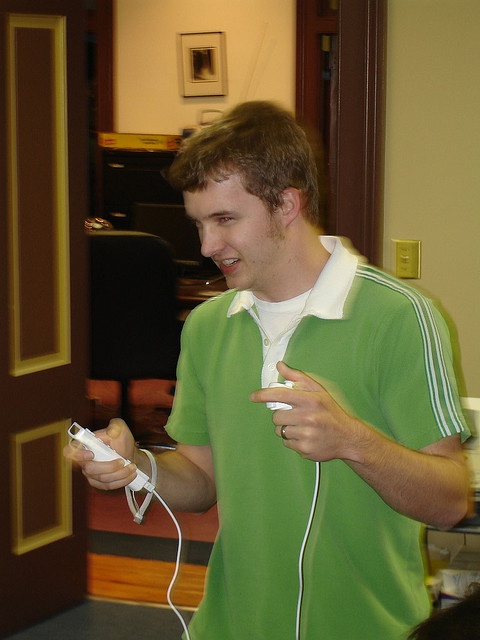Describe the objects in this image and their specific colors. I can see people in black, darkgreen, green, tan, and gray tones, chair in black, olive, maroon, and gray tones, tv in black tones, and remote in black, lightgray, darkgray, tan, and gray tones in this image. 